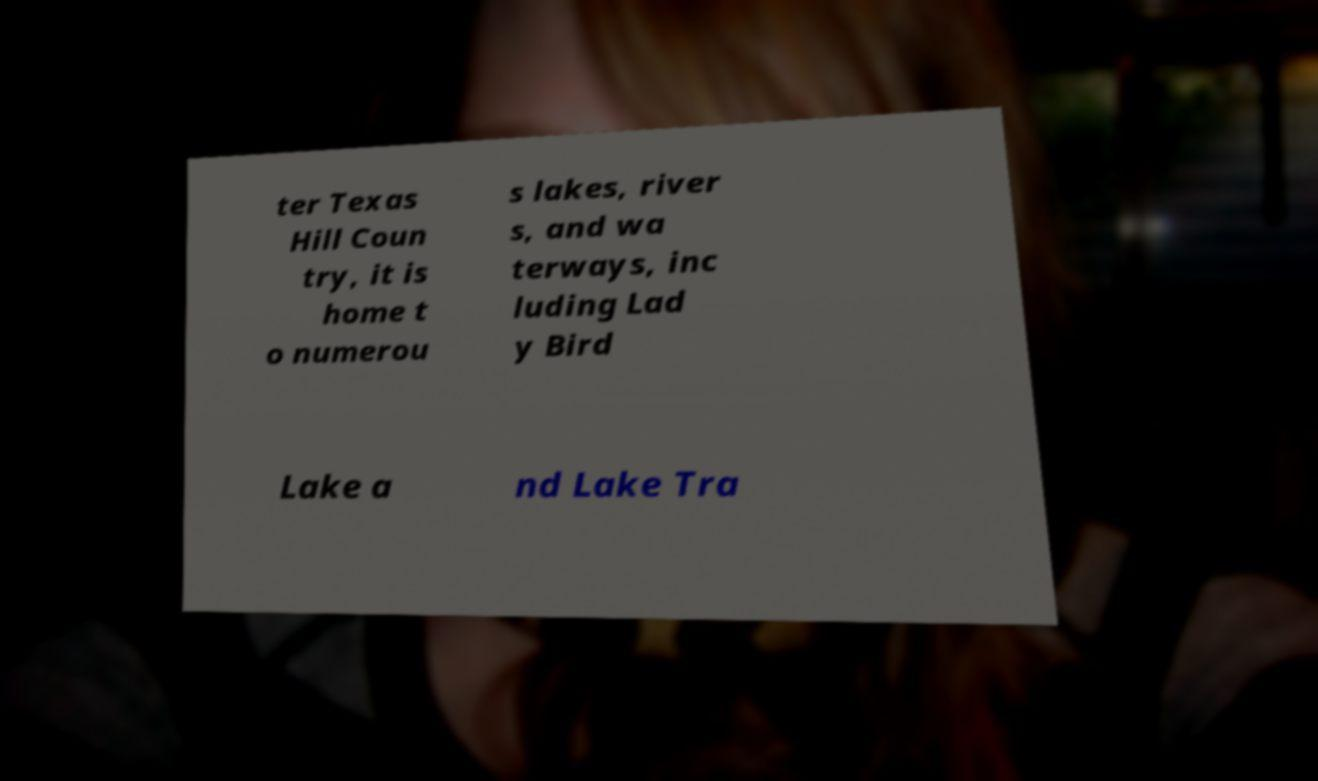Please read and relay the text visible in this image. What does it say? ter Texas Hill Coun try, it is home t o numerou s lakes, river s, and wa terways, inc luding Lad y Bird Lake a nd Lake Tra 